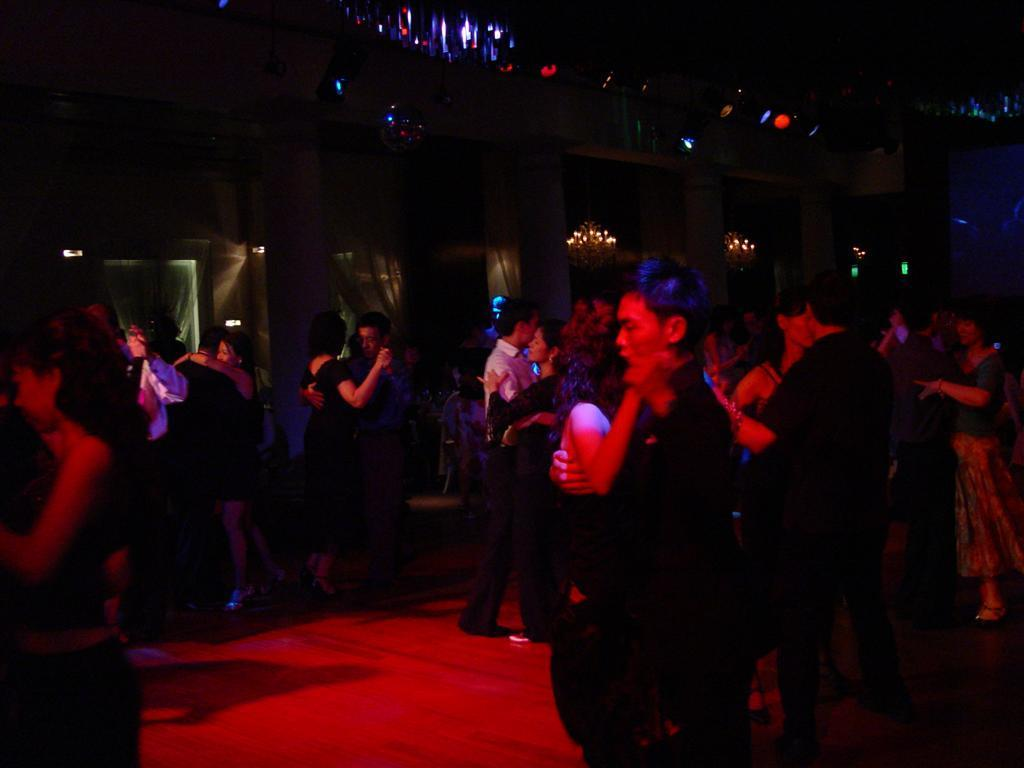What are the people in the image doing? The people are dancing in the image. Where is the dancing taking place? The dancing is taking place on a red carpet. What can be seen in the background of the image? There are chandeliers and lights in the background of the image. What type of chalk is being used by the people in the image? There is no chalk present in the image; the people are dancing on a red carpet. 